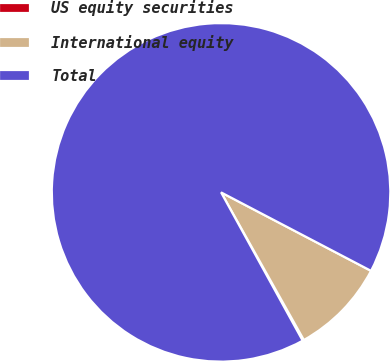Convert chart to OTSL. <chart><loc_0><loc_0><loc_500><loc_500><pie_chart><fcel>US equity securities<fcel>International equity<fcel>Total<nl><fcel>0.13%<fcel>9.19%<fcel>90.68%<nl></chart> 